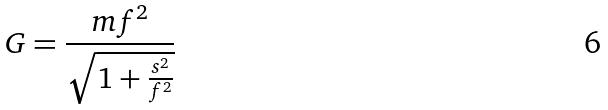Convert formula to latex. <formula><loc_0><loc_0><loc_500><loc_500>G = \frac { m f ^ { 2 } } { \sqrt { 1 + \frac { s ^ { 2 } } { f ^ { 2 } } } }</formula> 